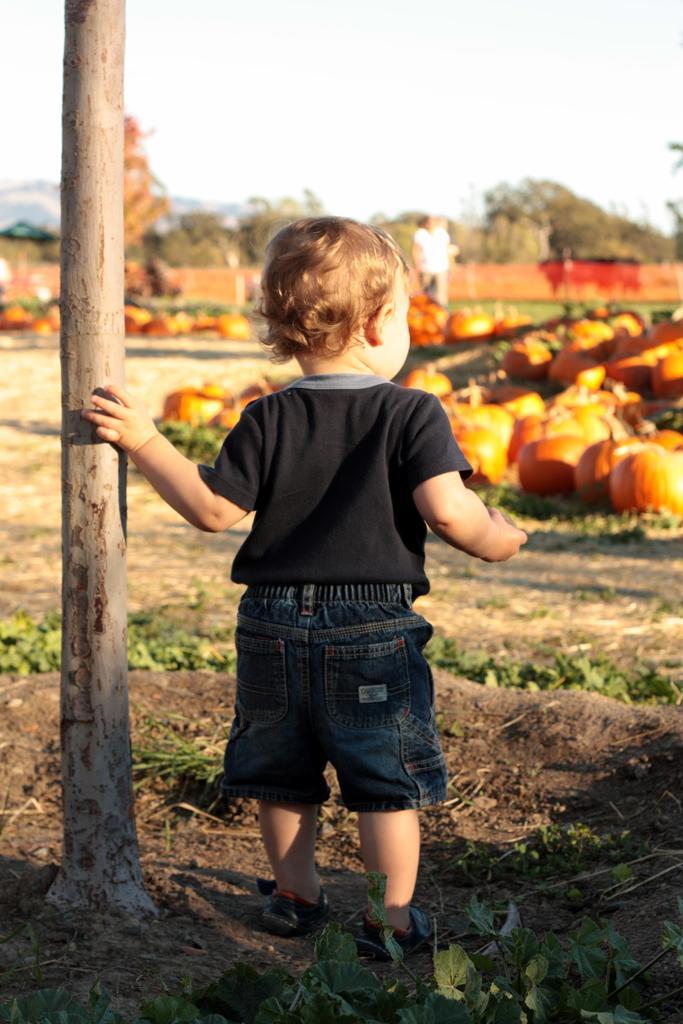Describe this image in one or two sentences. In this image we can see there is a little boy standing and placed his hand on the branch of a tree, in front of the person there are some pumpkin on the surface of the grass. In the background there is a person standing, trees and a sky. 